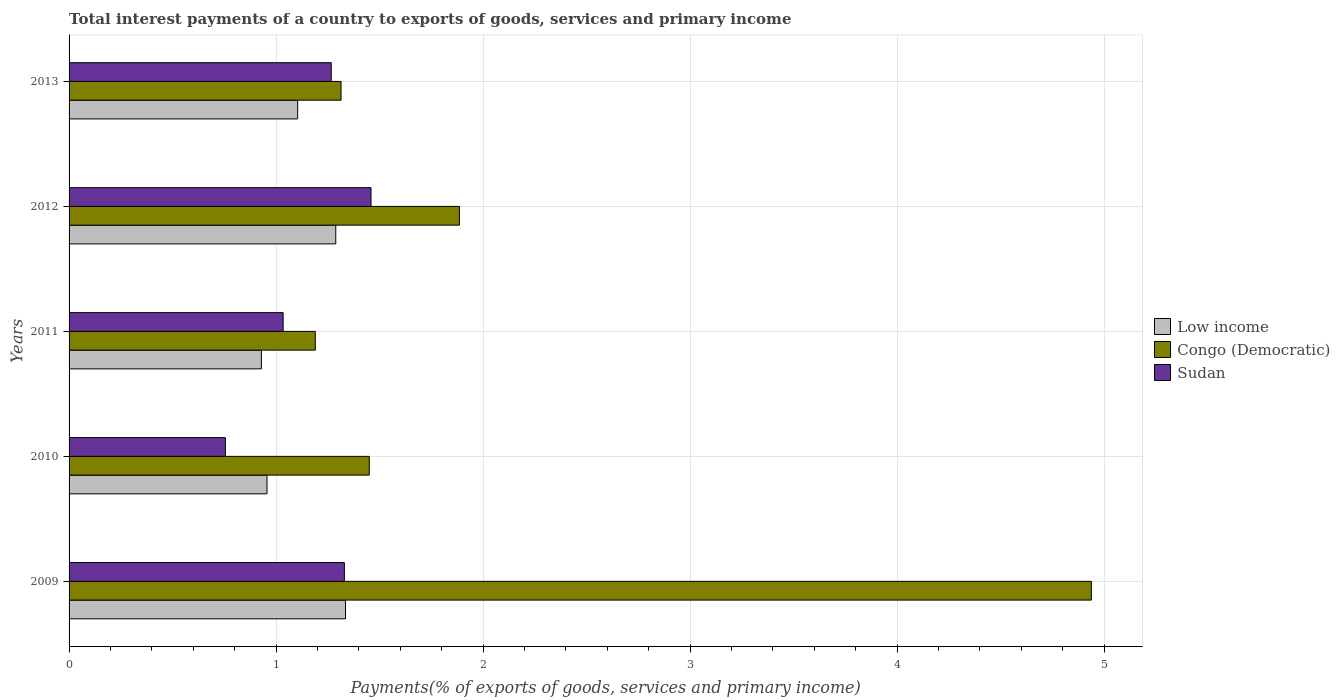How many different coloured bars are there?
Ensure brevity in your answer.  3. How many groups of bars are there?
Offer a very short reply. 5. How many bars are there on the 1st tick from the top?
Make the answer very short. 3. How many bars are there on the 5th tick from the bottom?
Ensure brevity in your answer.  3. What is the label of the 5th group of bars from the top?
Make the answer very short. 2009. In how many cases, is the number of bars for a given year not equal to the number of legend labels?
Your answer should be very brief. 0. What is the total interest payments in Sudan in 2013?
Your answer should be very brief. 1.27. Across all years, what is the maximum total interest payments in Sudan?
Give a very brief answer. 1.46. Across all years, what is the minimum total interest payments in Low income?
Ensure brevity in your answer.  0.93. What is the total total interest payments in Sudan in the graph?
Your response must be concise. 5.84. What is the difference between the total interest payments in Low income in 2009 and that in 2012?
Your answer should be compact. 0.05. What is the difference between the total interest payments in Low income in 2010 and the total interest payments in Congo (Democratic) in 2011?
Offer a very short reply. -0.23. What is the average total interest payments in Congo (Democratic) per year?
Ensure brevity in your answer.  2.16. In the year 2010, what is the difference between the total interest payments in Sudan and total interest payments in Low income?
Ensure brevity in your answer.  -0.2. In how many years, is the total interest payments in Congo (Democratic) greater than 1.2 %?
Your answer should be compact. 4. What is the ratio of the total interest payments in Low income in 2011 to that in 2013?
Your answer should be compact. 0.84. Is the difference between the total interest payments in Sudan in 2009 and 2010 greater than the difference between the total interest payments in Low income in 2009 and 2010?
Offer a very short reply. Yes. What is the difference between the highest and the second highest total interest payments in Low income?
Keep it short and to the point. 0.05. What is the difference between the highest and the lowest total interest payments in Congo (Democratic)?
Your answer should be very brief. 3.75. What does the 3rd bar from the bottom in 2010 represents?
Your response must be concise. Sudan. How many bars are there?
Give a very brief answer. 15. How many years are there in the graph?
Give a very brief answer. 5. What is the difference between two consecutive major ticks on the X-axis?
Make the answer very short. 1. Are the values on the major ticks of X-axis written in scientific E-notation?
Give a very brief answer. No. Does the graph contain any zero values?
Make the answer very short. No. Does the graph contain grids?
Your answer should be compact. Yes. Where does the legend appear in the graph?
Your response must be concise. Center right. How are the legend labels stacked?
Your answer should be compact. Vertical. What is the title of the graph?
Provide a succinct answer. Total interest payments of a country to exports of goods, services and primary income. What is the label or title of the X-axis?
Your answer should be very brief. Payments(% of exports of goods, services and primary income). What is the Payments(% of exports of goods, services and primary income) of Low income in 2009?
Give a very brief answer. 1.34. What is the Payments(% of exports of goods, services and primary income) in Congo (Democratic) in 2009?
Your answer should be compact. 4.94. What is the Payments(% of exports of goods, services and primary income) of Sudan in 2009?
Make the answer very short. 1.33. What is the Payments(% of exports of goods, services and primary income) in Low income in 2010?
Your response must be concise. 0.96. What is the Payments(% of exports of goods, services and primary income) of Congo (Democratic) in 2010?
Ensure brevity in your answer.  1.45. What is the Payments(% of exports of goods, services and primary income) of Sudan in 2010?
Offer a terse response. 0.76. What is the Payments(% of exports of goods, services and primary income) in Low income in 2011?
Ensure brevity in your answer.  0.93. What is the Payments(% of exports of goods, services and primary income) of Congo (Democratic) in 2011?
Make the answer very short. 1.19. What is the Payments(% of exports of goods, services and primary income) of Sudan in 2011?
Give a very brief answer. 1.03. What is the Payments(% of exports of goods, services and primary income) of Low income in 2012?
Your answer should be compact. 1.29. What is the Payments(% of exports of goods, services and primary income) of Congo (Democratic) in 2012?
Keep it short and to the point. 1.89. What is the Payments(% of exports of goods, services and primary income) in Sudan in 2012?
Provide a short and direct response. 1.46. What is the Payments(% of exports of goods, services and primary income) of Low income in 2013?
Ensure brevity in your answer.  1.1. What is the Payments(% of exports of goods, services and primary income) in Congo (Democratic) in 2013?
Ensure brevity in your answer.  1.31. What is the Payments(% of exports of goods, services and primary income) of Sudan in 2013?
Provide a succinct answer. 1.27. Across all years, what is the maximum Payments(% of exports of goods, services and primary income) of Low income?
Make the answer very short. 1.34. Across all years, what is the maximum Payments(% of exports of goods, services and primary income) in Congo (Democratic)?
Ensure brevity in your answer.  4.94. Across all years, what is the maximum Payments(% of exports of goods, services and primary income) of Sudan?
Offer a very short reply. 1.46. Across all years, what is the minimum Payments(% of exports of goods, services and primary income) of Low income?
Provide a succinct answer. 0.93. Across all years, what is the minimum Payments(% of exports of goods, services and primary income) in Congo (Democratic)?
Your answer should be compact. 1.19. Across all years, what is the minimum Payments(% of exports of goods, services and primary income) in Sudan?
Give a very brief answer. 0.76. What is the total Payments(% of exports of goods, services and primary income) in Low income in the graph?
Give a very brief answer. 5.61. What is the total Payments(% of exports of goods, services and primary income) of Congo (Democratic) in the graph?
Your answer should be very brief. 10.78. What is the total Payments(% of exports of goods, services and primary income) of Sudan in the graph?
Offer a terse response. 5.84. What is the difference between the Payments(% of exports of goods, services and primary income) in Low income in 2009 and that in 2010?
Make the answer very short. 0.38. What is the difference between the Payments(% of exports of goods, services and primary income) in Congo (Democratic) in 2009 and that in 2010?
Your answer should be very brief. 3.49. What is the difference between the Payments(% of exports of goods, services and primary income) of Sudan in 2009 and that in 2010?
Your answer should be very brief. 0.57. What is the difference between the Payments(% of exports of goods, services and primary income) in Low income in 2009 and that in 2011?
Provide a short and direct response. 0.41. What is the difference between the Payments(% of exports of goods, services and primary income) of Congo (Democratic) in 2009 and that in 2011?
Keep it short and to the point. 3.75. What is the difference between the Payments(% of exports of goods, services and primary income) in Sudan in 2009 and that in 2011?
Your answer should be compact. 0.3. What is the difference between the Payments(% of exports of goods, services and primary income) of Low income in 2009 and that in 2012?
Your answer should be very brief. 0.05. What is the difference between the Payments(% of exports of goods, services and primary income) in Congo (Democratic) in 2009 and that in 2012?
Your response must be concise. 3.05. What is the difference between the Payments(% of exports of goods, services and primary income) in Sudan in 2009 and that in 2012?
Make the answer very short. -0.13. What is the difference between the Payments(% of exports of goods, services and primary income) of Low income in 2009 and that in 2013?
Keep it short and to the point. 0.23. What is the difference between the Payments(% of exports of goods, services and primary income) of Congo (Democratic) in 2009 and that in 2013?
Offer a very short reply. 3.62. What is the difference between the Payments(% of exports of goods, services and primary income) of Sudan in 2009 and that in 2013?
Provide a short and direct response. 0.06. What is the difference between the Payments(% of exports of goods, services and primary income) in Low income in 2010 and that in 2011?
Keep it short and to the point. 0.03. What is the difference between the Payments(% of exports of goods, services and primary income) of Congo (Democratic) in 2010 and that in 2011?
Make the answer very short. 0.26. What is the difference between the Payments(% of exports of goods, services and primary income) in Sudan in 2010 and that in 2011?
Your response must be concise. -0.28. What is the difference between the Payments(% of exports of goods, services and primary income) of Low income in 2010 and that in 2012?
Offer a terse response. -0.33. What is the difference between the Payments(% of exports of goods, services and primary income) of Congo (Democratic) in 2010 and that in 2012?
Keep it short and to the point. -0.44. What is the difference between the Payments(% of exports of goods, services and primary income) of Sudan in 2010 and that in 2012?
Give a very brief answer. -0.7. What is the difference between the Payments(% of exports of goods, services and primary income) in Low income in 2010 and that in 2013?
Your answer should be very brief. -0.15. What is the difference between the Payments(% of exports of goods, services and primary income) of Congo (Democratic) in 2010 and that in 2013?
Your answer should be very brief. 0.14. What is the difference between the Payments(% of exports of goods, services and primary income) in Sudan in 2010 and that in 2013?
Your answer should be very brief. -0.51. What is the difference between the Payments(% of exports of goods, services and primary income) of Low income in 2011 and that in 2012?
Offer a very short reply. -0.36. What is the difference between the Payments(% of exports of goods, services and primary income) in Congo (Democratic) in 2011 and that in 2012?
Keep it short and to the point. -0.7. What is the difference between the Payments(% of exports of goods, services and primary income) of Sudan in 2011 and that in 2012?
Provide a succinct answer. -0.42. What is the difference between the Payments(% of exports of goods, services and primary income) of Low income in 2011 and that in 2013?
Offer a very short reply. -0.18. What is the difference between the Payments(% of exports of goods, services and primary income) of Congo (Democratic) in 2011 and that in 2013?
Keep it short and to the point. -0.12. What is the difference between the Payments(% of exports of goods, services and primary income) in Sudan in 2011 and that in 2013?
Ensure brevity in your answer.  -0.23. What is the difference between the Payments(% of exports of goods, services and primary income) of Low income in 2012 and that in 2013?
Your response must be concise. 0.18. What is the difference between the Payments(% of exports of goods, services and primary income) of Congo (Democratic) in 2012 and that in 2013?
Give a very brief answer. 0.57. What is the difference between the Payments(% of exports of goods, services and primary income) in Sudan in 2012 and that in 2013?
Your response must be concise. 0.19. What is the difference between the Payments(% of exports of goods, services and primary income) in Low income in 2009 and the Payments(% of exports of goods, services and primary income) in Congo (Democratic) in 2010?
Provide a succinct answer. -0.11. What is the difference between the Payments(% of exports of goods, services and primary income) of Low income in 2009 and the Payments(% of exports of goods, services and primary income) of Sudan in 2010?
Your answer should be very brief. 0.58. What is the difference between the Payments(% of exports of goods, services and primary income) in Congo (Democratic) in 2009 and the Payments(% of exports of goods, services and primary income) in Sudan in 2010?
Give a very brief answer. 4.18. What is the difference between the Payments(% of exports of goods, services and primary income) of Low income in 2009 and the Payments(% of exports of goods, services and primary income) of Congo (Democratic) in 2011?
Your answer should be compact. 0.15. What is the difference between the Payments(% of exports of goods, services and primary income) of Low income in 2009 and the Payments(% of exports of goods, services and primary income) of Sudan in 2011?
Make the answer very short. 0.3. What is the difference between the Payments(% of exports of goods, services and primary income) of Congo (Democratic) in 2009 and the Payments(% of exports of goods, services and primary income) of Sudan in 2011?
Make the answer very short. 3.9. What is the difference between the Payments(% of exports of goods, services and primary income) of Low income in 2009 and the Payments(% of exports of goods, services and primary income) of Congo (Democratic) in 2012?
Offer a very short reply. -0.55. What is the difference between the Payments(% of exports of goods, services and primary income) of Low income in 2009 and the Payments(% of exports of goods, services and primary income) of Sudan in 2012?
Ensure brevity in your answer.  -0.12. What is the difference between the Payments(% of exports of goods, services and primary income) of Congo (Democratic) in 2009 and the Payments(% of exports of goods, services and primary income) of Sudan in 2012?
Ensure brevity in your answer.  3.48. What is the difference between the Payments(% of exports of goods, services and primary income) of Low income in 2009 and the Payments(% of exports of goods, services and primary income) of Congo (Democratic) in 2013?
Offer a terse response. 0.02. What is the difference between the Payments(% of exports of goods, services and primary income) of Low income in 2009 and the Payments(% of exports of goods, services and primary income) of Sudan in 2013?
Give a very brief answer. 0.07. What is the difference between the Payments(% of exports of goods, services and primary income) in Congo (Democratic) in 2009 and the Payments(% of exports of goods, services and primary income) in Sudan in 2013?
Your answer should be very brief. 3.67. What is the difference between the Payments(% of exports of goods, services and primary income) of Low income in 2010 and the Payments(% of exports of goods, services and primary income) of Congo (Democratic) in 2011?
Provide a short and direct response. -0.23. What is the difference between the Payments(% of exports of goods, services and primary income) in Low income in 2010 and the Payments(% of exports of goods, services and primary income) in Sudan in 2011?
Offer a very short reply. -0.08. What is the difference between the Payments(% of exports of goods, services and primary income) in Congo (Democratic) in 2010 and the Payments(% of exports of goods, services and primary income) in Sudan in 2011?
Offer a terse response. 0.42. What is the difference between the Payments(% of exports of goods, services and primary income) in Low income in 2010 and the Payments(% of exports of goods, services and primary income) in Congo (Democratic) in 2012?
Provide a short and direct response. -0.93. What is the difference between the Payments(% of exports of goods, services and primary income) in Low income in 2010 and the Payments(% of exports of goods, services and primary income) in Sudan in 2012?
Ensure brevity in your answer.  -0.5. What is the difference between the Payments(% of exports of goods, services and primary income) of Congo (Democratic) in 2010 and the Payments(% of exports of goods, services and primary income) of Sudan in 2012?
Provide a succinct answer. -0.01. What is the difference between the Payments(% of exports of goods, services and primary income) of Low income in 2010 and the Payments(% of exports of goods, services and primary income) of Congo (Democratic) in 2013?
Keep it short and to the point. -0.36. What is the difference between the Payments(% of exports of goods, services and primary income) in Low income in 2010 and the Payments(% of exports of goods, services and primary income) in Sudan in 2013?
Provide a short and direct response. -0.31. What is the difference between the Payments(% of exports of goods, services and primary income) in Congo (Democratic) in 2010 and the Payments(% of exports of goods, services and primary income) in Sudan in 2013?
Offer a very short reply. 0.18. What is the difference between the Payments(% of exports of goods, services and primary income) in Low income in 2011 and the Payments(% of exports of goods, services and primary income) in Congo (Democratic) in 2012?
Keep it short and to the point. -0.96. What is the difference between the Payments(% of exports of goods, services and primary income) in Low income in 2011 and the Payments(% of exports of goods, services and primary income) in Sudan in 2012?
Provide a succinct answer. -0.53. What is the difference between the Payments(% of exports of goods, services and primary income) of Congo (Democratic) in 2011 and the Payments(% of exports of goods, services and primary income) of Sudan in 2012?
Keep it short and to the point. -0.27. What is the difference between the Payments(% of exports of goods, services and primary income) of Low income in 2011 and the Payments(% of exports of goods, services and primary income) of Congo (Democratic) in 2013?
Your response must be concise. -0.38. What is the difference between the Payments(% of exports of goods, services and primary income) in Low income in 2011 and the Payments(% of exports of goods, services and primary income) in Sudan in 2013?
Keep it short and to the point. -0.34. What is the difference between the Payments(% of exports of goods, services and primary income) in Congo (Democratic) in 2011 and the Payments(% of exports of goods, services and primary income) in Sudan in 2013?
Make the answer very short. -0.08. What is the difference between the Payments(% of exports of goods, services and primary income) of Low income in 2012 and the Payments(% of exports of goods, services and primary income) of Congo (Democratic) in 2013?
Ensure brevity in your answer.  -0.03. What is the difference between the Payments(% of exports of goods, services and primary income) of Low income in 2012 and the Payments(% of exports of goods, services and primary income) of Sudan in 2013?
Provide a short and direct response. 0.02. What is the difference between the Payments(% of exports of goods, services and primary income) of Congo (Democratic) in 2012 and the Payments(% of exports of goods, services and primary income) of Sudan in 2013?
Keep it short and to the point. 0.62. What is the average Payments(% of exports of goods, services and primary income) of Low income per year?
Provide a short and direct response. 1.12. What is the average Payments(% of exports of goods, services and primary income) in Congo (Democratic) per year?
Provide a succinct answer. 2.16. What is the average Payments(% of exports of goods, services and primary income) in Sudan per year?
Your answer should be very brief. 1.17. In the year 2009, what is the difference between the Payments(% of exports of goods, services and primary income) of Low income and Payments(% of exports of goods, services and primary income) of Congo (Democratic)?
Offer a very short reply. -3.6. In the year 2009, what is the difference between the Payments(% of exports of goods, services and primary income) of Low income and Payments(% of exports of goods, services and primary income) of Sudan?
Your answer should be very brief. 0.01. In the year 2009, what is the difference between the Payments(% of exports of goods, services and primary income) of Congo (Democratic) and Payments(% of exports of goods, services and primary income) of Sudan?
Make the answer very short. 3.61. In the year 2010, what is the difference between the Payments(% of exports of goods, services and primary income) in Low income and Payments(% of exports of goods, services and primary income) in Congo (Democratic)?
Your answer should be compact. -0.49. In the year 2010, what is the difference between the Payments(% of exports of goods, services and primary income) in Low income and Payments(% of exports of goods, services and primary income) in Sudan?
Your response must be concise. 0.2. In the year 2010, what is the difference between the Payments(% of exports of goods, services and primary income) of Congo (Democratic) and Payments(% of exports of goods, services and primary income) of Sudan?
Offer a terse response. 0.7. In the year 2011, what is the difference between the Payments(% of exports of goods, services and primary income) in Low income and Payments(% of exports of goods, services and primary income) in Congo (Democratic)?
Give a very brief answer. -0.26. In the year 2011, what is the difference between the Payments(% of exports of goods, services and primary income) in Low income and Payments(% of exports of goods, services and primary income) in Sudan?
Ensure brevity in your answer.  -0.11. In the year 2011, what is the difference between the Payments(% of exports of goods, services and primary income) in Congo (Democratic) and Payments(% of exports of goods, services and primary income) in Sudan?
Your answer should be very brief. 0.16. In the year 2012, what is the difference between the Payments(% of exports of goods, services and primary income) of Low income and Payments(% of exports of goods, services and primary income) of Congo (Democratic)?
Your answer should be compact. -0.6. In the year 2012, what is the difference between the Payments(% of exports of goods, services and primary income) of Low income and Payments(% of exports of goods, services and primary income) of Sudan?
Give a very brief answer. -0.17. In the year 2012, what is the difference between the Payments(% of exports of goods, services and primary income) in Congo (Democratic) and Payments(% of exports of goods, services and primary income) in Sudan?
Give a very brief answer. 0.43. In the year 2013, what is the difference between the Payments(% of exports of goods, services and primary income) in Low income and Payments(% of exports of goods, services and primary income) in Congo (Democratic)?
Offer a very short reply. -0.21. In the year 2013, what is the difference between the Payments(% of exports of goods, services and primary income) of Low income and Payments(% of exports of goods, services and primary income) of Sudan?
Provide a succinct answer. -0.16. In the year 2013, what is the difference between the Payments(% of exports of goods, services and primary income) in Congo (Democratic) and Payments(% of exports of goods, services and primary income) in Sudan?
Your answer should be very brief. 0.05. What is the ratio of the Payments(% of exports of goods, services and primary income) in Low income in 2009 to that in 2010?
Offer a terse response. 1.4. What is the ratio of the Payments(% of exports of goods, services and primary income) in Congo (Democratic) in 2009 to that in 2010?
Provide a short and direct response. 3.41. What is the ratio of the Payments(% of exports of goods, services and primary income) of Sudan in 2009 to that in 2010?
Keep it short and to the point. 1.76. What is the ratio of the Payments(% of exports of goods, services and primary income) of Low income in 2009 to that in 2011?
Make the answer very short. 1.44. What is the ratio of the Payments(% of exports of goods, services and primary income) in Congo (Democratic) in 2009 to that in 2011?
Keep it short and to the point. 4.15. What is the ratio of the Payments(% of exports of goods, services and primary income) of Sudan in 2009 to that in 2011?
Your response must be concise. 1.29. What is the ratio of the Payments(% of exports of goods, services and primary income) of Low income in 2009 to that in 2012?
Your response must be concise. 1.04. What is the ratio of the Payments(% of exports of goods, services and primary income) in Congo (Democratic) in 2009 to that in 2012?
Ensure brevity in your answer.  2.62. What is the ratio of the Payments(% of exports of goods, services and primary income) of Sudan in 2009 to that in 2012?
Ensure brevity in your answer.  0.91. What is the ratio of the Payments(% of exports of goods, services and primary income) in Low income in 2009 to that in 2013?
Give a very brief answer. 1.21. What is the ratio of the Payments(% of exports of goods, services and primary income) in Congo (Democratic) in 2009 to that in 2013?
Offer a terse response. 3.76. What is the ratio of the Payments(% of exports of goods, services and primary income) of Sudan in 2009 to that in 2013?
Your answer should be very brief. 1.05. What is the ratio of the Payments(% of exports of goods, services and primary income) of Low income in 2010 to that in 2011?
Give a very brief answer. 1.03. What is the ratio of the Payments(% of exports of goods, services and primary income) in Congo (Democratic) in 2010 to that in 2011?
Make the answer very short. 1.22. What is the ratio of the Payments(% of exports of goods, services and primary income) of Sudan in 2010 to that in 2011?
Your response must be concise. 0.73. What is the ratio of the Payments(% of exports of goods, services and primary income) of Low income in 2010 to that in 2012?
Keep it short and to the point. 0.74. What is the ratio of the Payments(% of exports of goods, services and primary income) of Congo (Democratic) in 2010 to that in 2012?
Your answer should be very brief. 0.77. What is the ratio of the Payments(% of exports of goods, services and primary income) in Sudan in 2010 to that in 2012?
Make the answer very short. 0.52. What is the ratio of the Payments(% of exports of goods, services and primary income) in Low income in 2010 to that in 2013?
Ensure brevity in your answer.  0.87. What is the ratio of the Payments(% of exports of goods, services and primary income) of Congo (Democratic) in 2010 to that in 2013?
Make the answer very short. 1.1. What is the ratio of the Payments(% of exports of goods, services and primary income) in Sudan in 2010 to that in 2013?
Keep it short and to the point. 0.6. What is the ratio of the Payments(% of exports of goods, services and primary income) of Low income in 2011 to that in 2012?
Your answer should be compact. 0.72. What is the ratio of the Payments(% of exports of goods, services and primary income) of Congo (Democratic) in 2011 to that in 2012?
Make the answer very short. 0.63. What is the ratio of the Payments(% of exports of goods, services and primary income) in Sudan in 2011 to that in 2012?
Offer a terse response. 0.71. What is the ratio of the Payments(% of exports of goods, services and primary income) of Low income in 2011 to that in 2013?
Your answer should be compact. 0.84. What is the ratio of the Payments(% of exports of goods, services and primary income) of Congo (Democratic) in 2011 to that in 2013?
Give a very brief answer. 0.91. What is the ratio of the Payments(% of exports of goods, services and primary income) of Sudan in 2011 to that in 2013?
Provide a succinct answer. 0.82. What is the ratio of the Payments(% of exports of goods, services and primary income) of Low income in 2012 to that in 2013?
Your response must be concise. 1.17. What is the ratio of the Payments(% of exports of goods, services and primary income) in Congo (Democratic) in 2012 to that in 2013?
Your answer should be compact. 1.44. What is the ratio of the Payments(% of exports of goods, services and primary income) in Sudan in 2012 to that in 2013?
Ensure brevity in your answer.  1.15. What is the difference between the highest and the second highest Payments(% of exports of goods, services and primary income) in Low income?
Offer a very short reply. 0.05. What is the difference between the highest and the second highest Payments(% of exports of goods, services and primary income) in Congo (Democratic)?
Your answer should be very brief. 3.05. What is the difference between the highest and the second highest Payments(% of exports of goods, services and primary income) in Sudan?
Make the answer very short. 0.13. What is the difference between the highest and the lowest Payments(% of exports of goods, services and primary income) in Low income?
Ensure brevity in your answer.  0.41. What is the difference between the highest and the lowest Payments(% of exports of goods, services and primary income) in Congo (Democratic)?
Offer a very short reply. 3.75. What is the difference between the highest and the lowest Payments(% of exports of goods, services and primary income) of Sudan?
Your answer should be very brief. 0.7. 